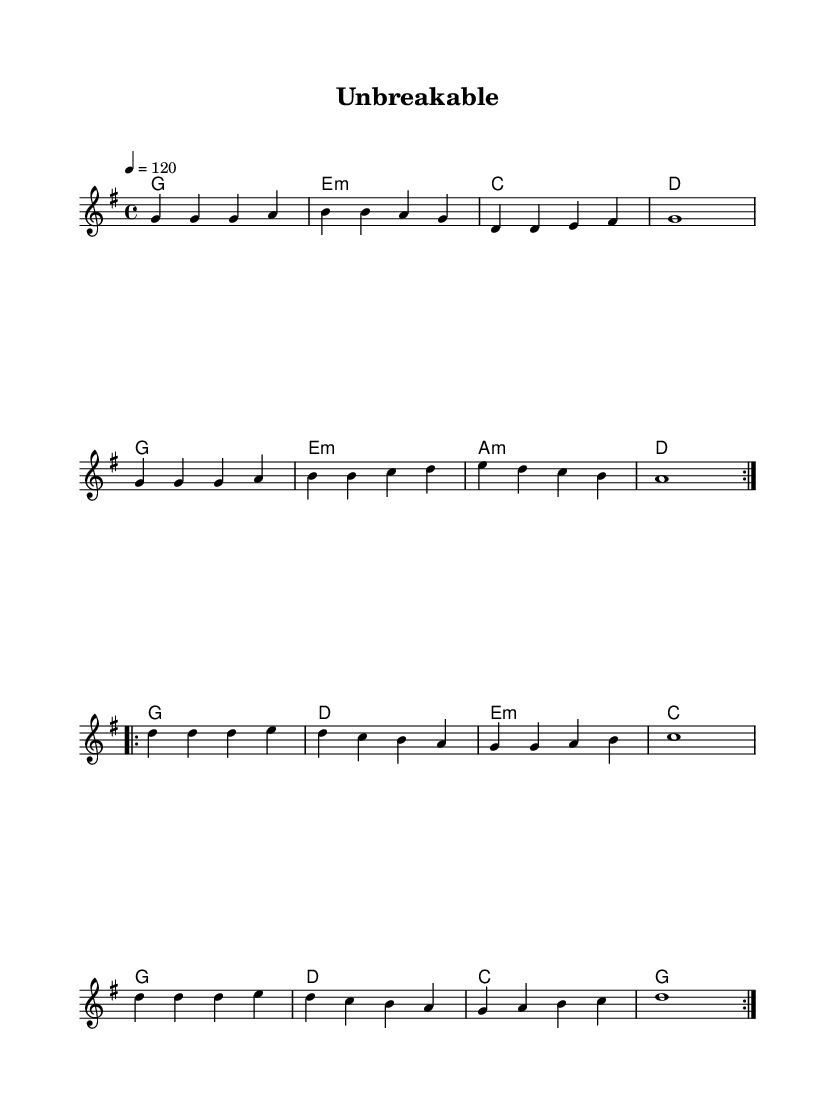What is the key signature of this music? The key signature is G major, which has one sharp (F#). This is visible at the beginning of the staff where the key signature is indicated.
Answer: G major What is the time signature of this music? The time signature is 4/4, which indicates four beats in a measure and is also represented at the beginning of the music.
Answer: 4/4 What is the tempo marking for this piece? The tempo marking is 120 beats per minute, which directs performers on how fast to play the piece and is specified at the beginning of the score.
Answer: 120 How many times is the first section repeated? The first section is repeated two times, indicated by the repeat signs at the beginning and end of the section.
Answer: 2 What chord follows the G major chord in the first section? The chord that follows G major in the first section is E minor, as seen in the chord progression line just after the G major.
Answer: E minor What is the primary theme of this music in terms of K-Pop characteristics? The primary theme is empowerment and resilience, which is a common theme in K-Pop girl group songs that celebrate female strength. This can be inferred from the title "Unbreakable."
Answer: Empowerment 